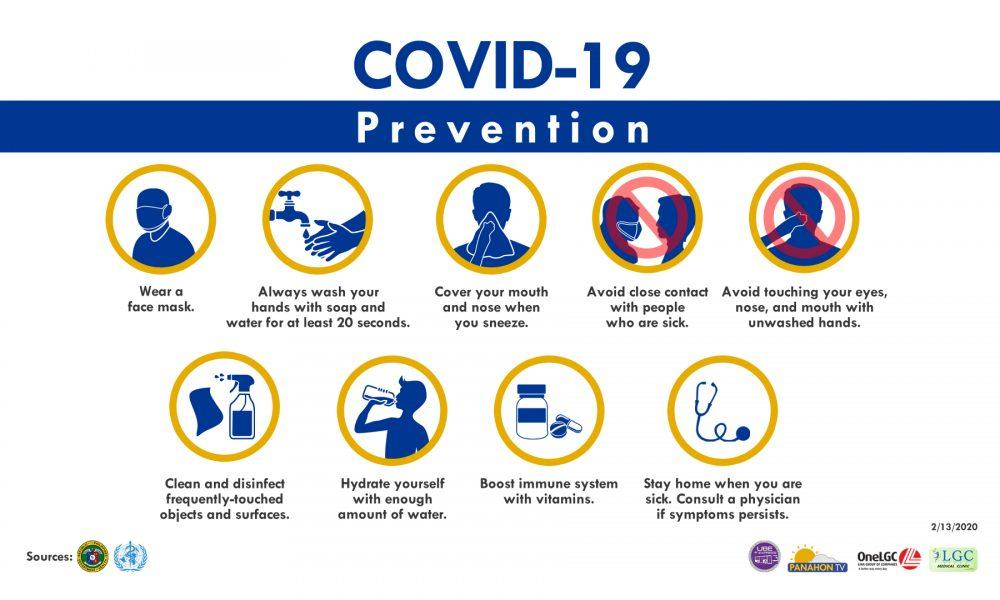Point out several critical features in this image. The face comprises several distinct parts, including the eyes, nose, and mouth. Nine preventive measures are featured in this infographic. 